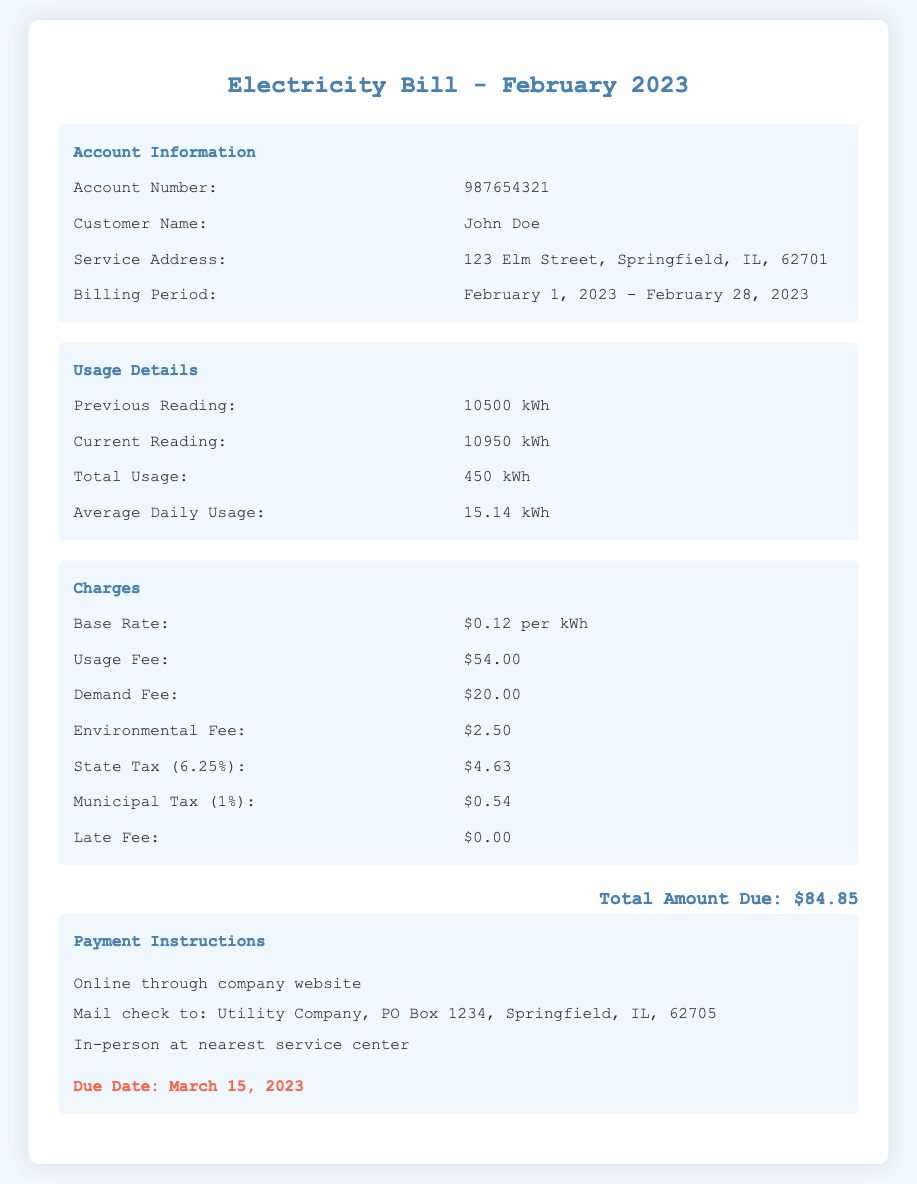What is the account number? The account number is specified in the Account Information section of the document.
Answer: 987654321 What is the customer name? The customer name is provided in the Account Information section.
Answer: John Doe What is the billing period? The billing period indicates the time frame for which the bill is issued, mentioned in the Account Information section.
Answer: February 1, 2023 - February 28, 2023 How much is the base rate per kWh? The base rate is outlined in the Charges section of the bill.
Answer: $0.12 per kWh What is the total usage in kWh? Total usage is calculated from the difference between the previous and current readings as shown in the Usage Details section.
Answer: 450 kWh What is the total amount due? The total amount due is presented in the total section at the end of the document.
Answer: $84.85 What is the due date for the bill payment? The due date is mentioned in the Payment Instructions section.
Answer: March 15, 2023 What is the municipal tax percentage? The municipal tax percentage is part of the Charges breakdown included in the document.
Answer: 1% What payment methods are available? Payment methods are listed in the Payment Instructions section, detailing how to pay the bill.
Answer: Online, Mail, In-person 